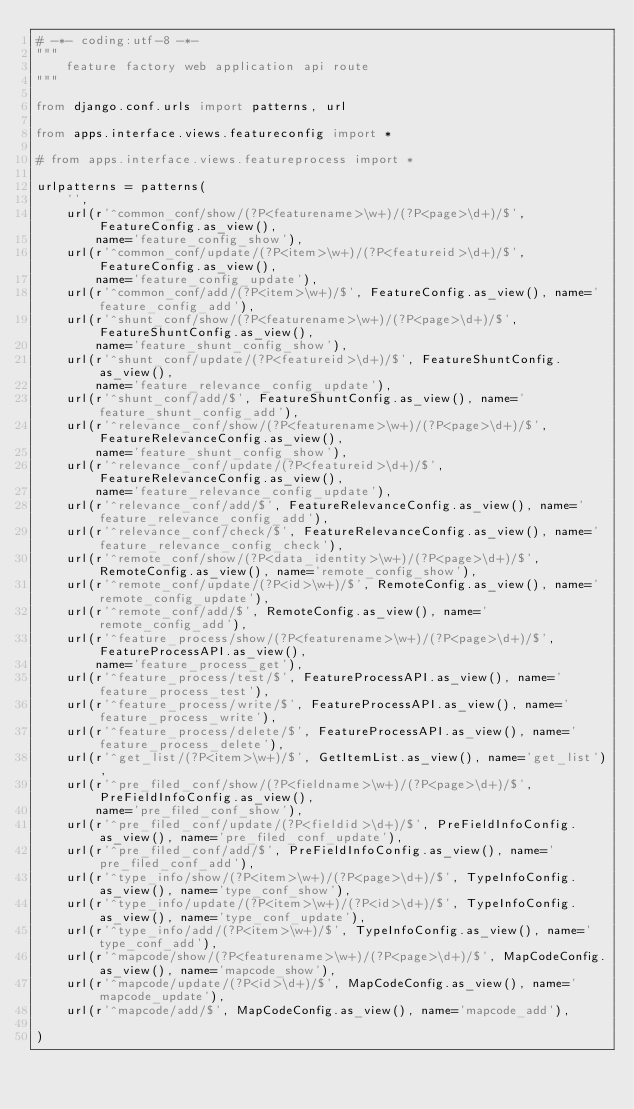Convert code to text. <code><loc_0><loc_0><loc_500><loc_500><_Python_># -*- coding:utf-8 -*-
"""
    feature factory web application api route
"""

from django.conf.urls import patterns, url

from apps.interface.views.featureconfig import *

# from apps.interface.views.featureprocess import *

urlpatterns = patterns(
    '',
    url(r'^common_conf/show/(?P<featurename>\w+)/(?P<page>\d+)/$', FeatureConfig.as_view(),
        name='feature_config_show'),
    url(r'^common_conf/update/(?P<item>\w+)/(?P<featureid>\d+)/$', FeatureConfig.as_view(),
        name='feature_config_update'),
    url(r'^common_conf/add/(?P<item>\w+)/$', FeatureConfig.as_view(), name='feature_config_add'),
    url(r'^shunt_conf/show/(?P<featurename>\w+)/(?P<page>\d+)/$', FeatureShuntConfig.as_view(),
        name='feature_shunt_config_show'),
    url(r'^shunt_conf/update/(?P<featureid>\d+)/$', FeatureShuntConfig.as_view(),
        name='feature_relevance_config_update'),
    url(r'^shunt_conf/add/$', FeatureShuntConfig.as_view(), name='feature_shunt_config_add'),
    url(r'^relevance_conf/show/(?P<featurename>\w+)/(?P<page>\d+)/$', FeatureRelevanceConfig.as_view(),
        name='feature_shunt_config_show'),
    url(r'^relevance_conf/update/(?P<featureid>\d+)/$', FeatureRelevanceConfig.as_view(),
        name='feature_relevance_config_update'),
    url(r'^relevance_conf/add/$', FeatureRelevanceConfig.as_view(), name='feature_relevance_config_add'),
    url(r'^relevance_conf/check/$', FeatureRelevanceConfig.as_view(), name='feature_relevance_config_check'),
    url(r'^remote_conf/show/(?P<data_identity>\w+)/(?P<page>\d+)/$', RemoteConfig.as_view(), name='remote_config_show'),
    url(r'^remote_conf/update/(?P<id>\w+)/$', RemoteConfig.as_view(), name='remote_config_update'),
    url(r'^remote_conf/add/$', RemoteConfig.as_view(), name='remote_config_add'),
    url(r'^feature_process/show/(?P<featurename>\w+)/(?P<page>\d+)/$', FeatureProcessAPI.as_view(),
        name='feature_process_get'),
    url(r'^feature_process/test/$', FeatureProcessAPI.as_view(), name='feature_process_test'),
    url(r'^feature_process/write/$', FeatureProcessAPI.as_view(), name='feature_process_write'),
    url(r'^feature_process/delete/$', FeatureProcessAPI.as_view(), name='feature_process_delete'),
    url(r'^get_list/(?P<item>\w+)/$', GetItemList.as_view(), name='get_list'),
    url(r'^pre_filed_conf/show/(?P<fieldname>\w+)/(?P<page>\d+)/$', PreFieldInfoConfig.as_view(),
        name='pre_filed_conf_show'),
    url(r'^pre_filed_conf/update/(?P<fieldid>\d+)/$', PreFieldInfoConfig.as_view(), name='pre_filed_conf_update'),
    url(r'^pre_filed_conf/add/$', PreFieldInfoConfig.as_view(), name='pre_filed_conf_add'),
    url(r'^type_info/show/(?P<item>\w+)/(?P<page>\d+)/$', TypeInfoConfig.as_view(), name='type_conf_show'),
    url(r'^type_info/update/(?P<item>\w+)/(?P<id>\d+)/$', TypeInfoConfig.as_view(), name='type_conf_update'),
    url(r'^type_info/add/(?P<item>\w+)/$', TypeInfoConfig.as_view(), name='type_conf_add'),
    url(r'^mapcode/show/(?P<featurename>\w+)/(?P<page>\d+)/$', MapCodeConfig.as_view(), name='mapcode_show'),
    url(r'^mapcode/update/(?P<id>\d+)/$', MapCodeConfig.as_view(), name='mapcode_update'),
    url(r'^mapcode/add/$', MapCodeConfig.as_view(), name='mapcode_add'),

)
</code> 